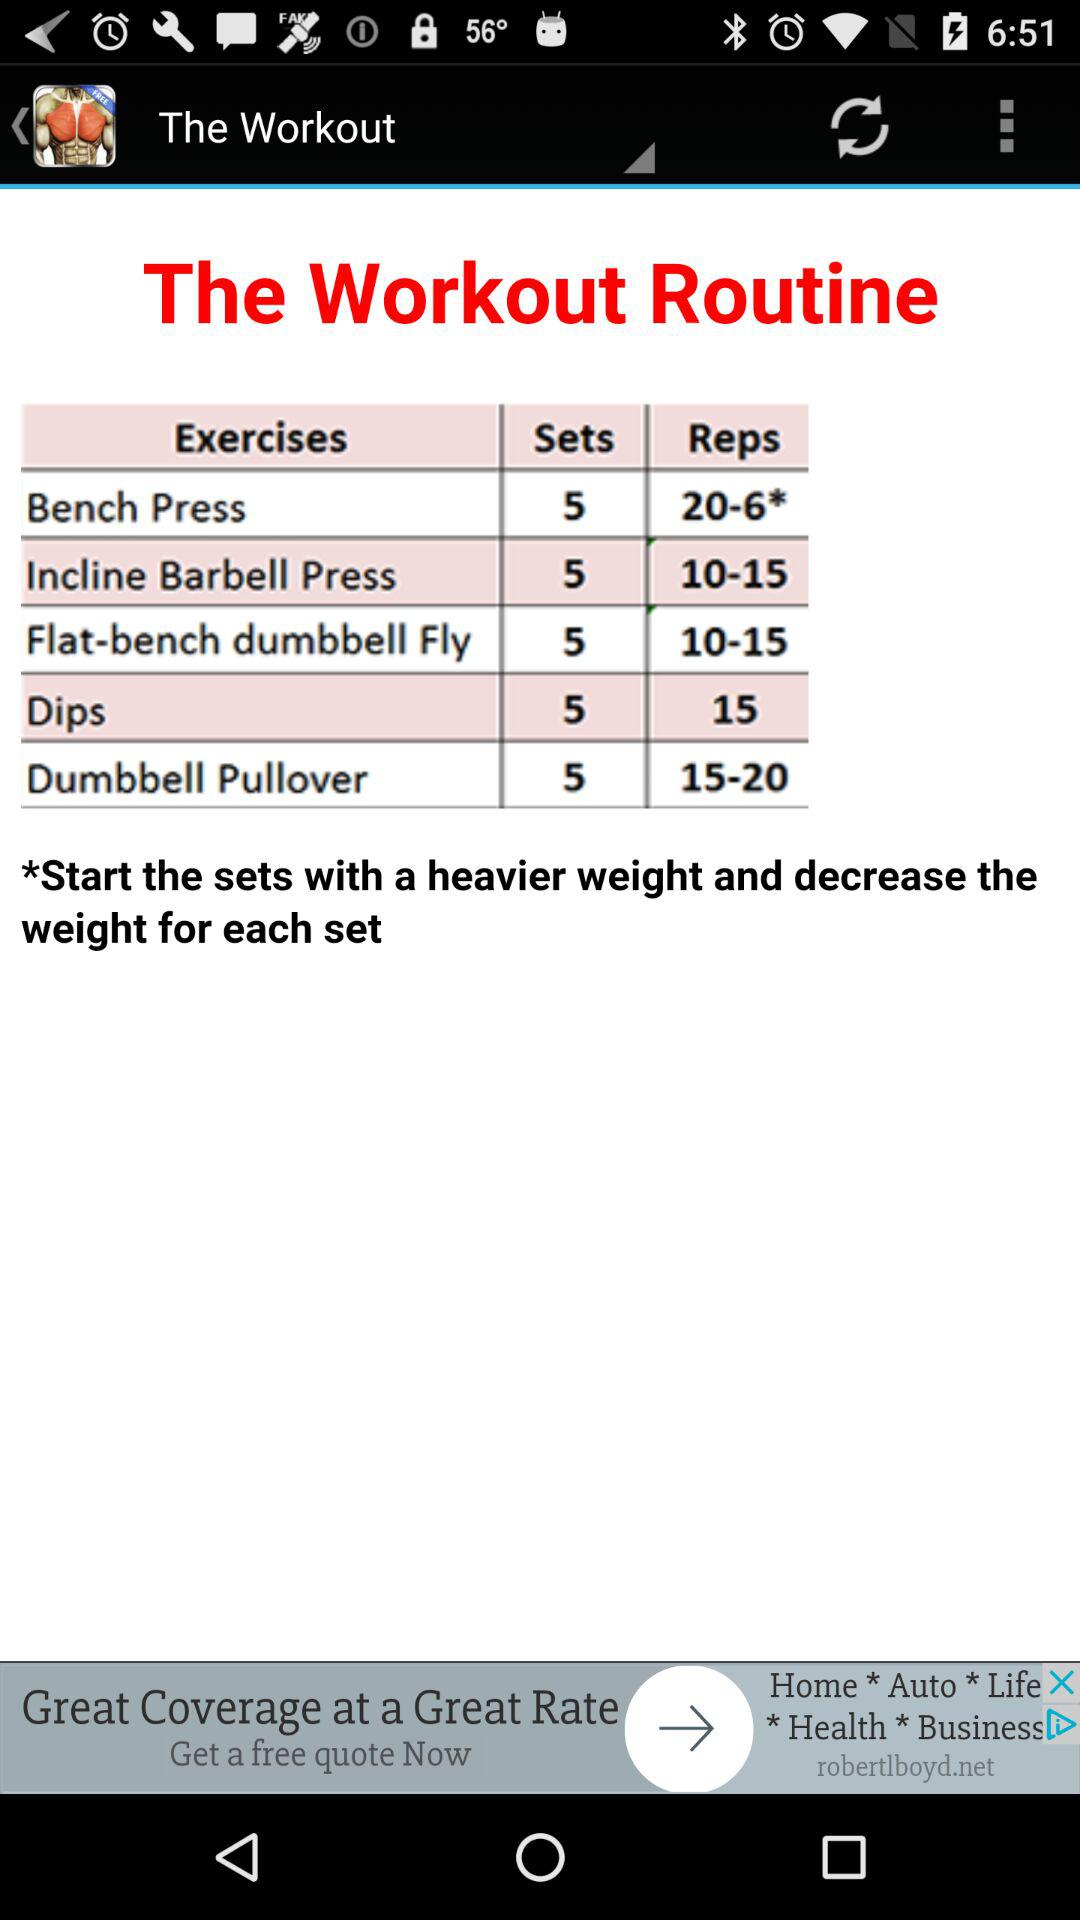How many sets of "Incline Barbell Press" should I do? You should do 5 sets of "Incline Barbell Press". 